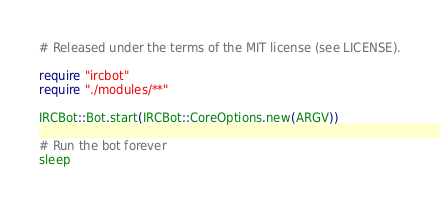Convert code to text. <code><loc_0><loc_0><loc_500><loc_500><_Crystal_># Released under the terms of the MIT license (see LICENSE).

require "ircbot"
require "./modules/**"

IRCBot::Bot.start(IRCBot::CoreOptions.new(ARGV))

# Run the bot forever
sleep
</code> 